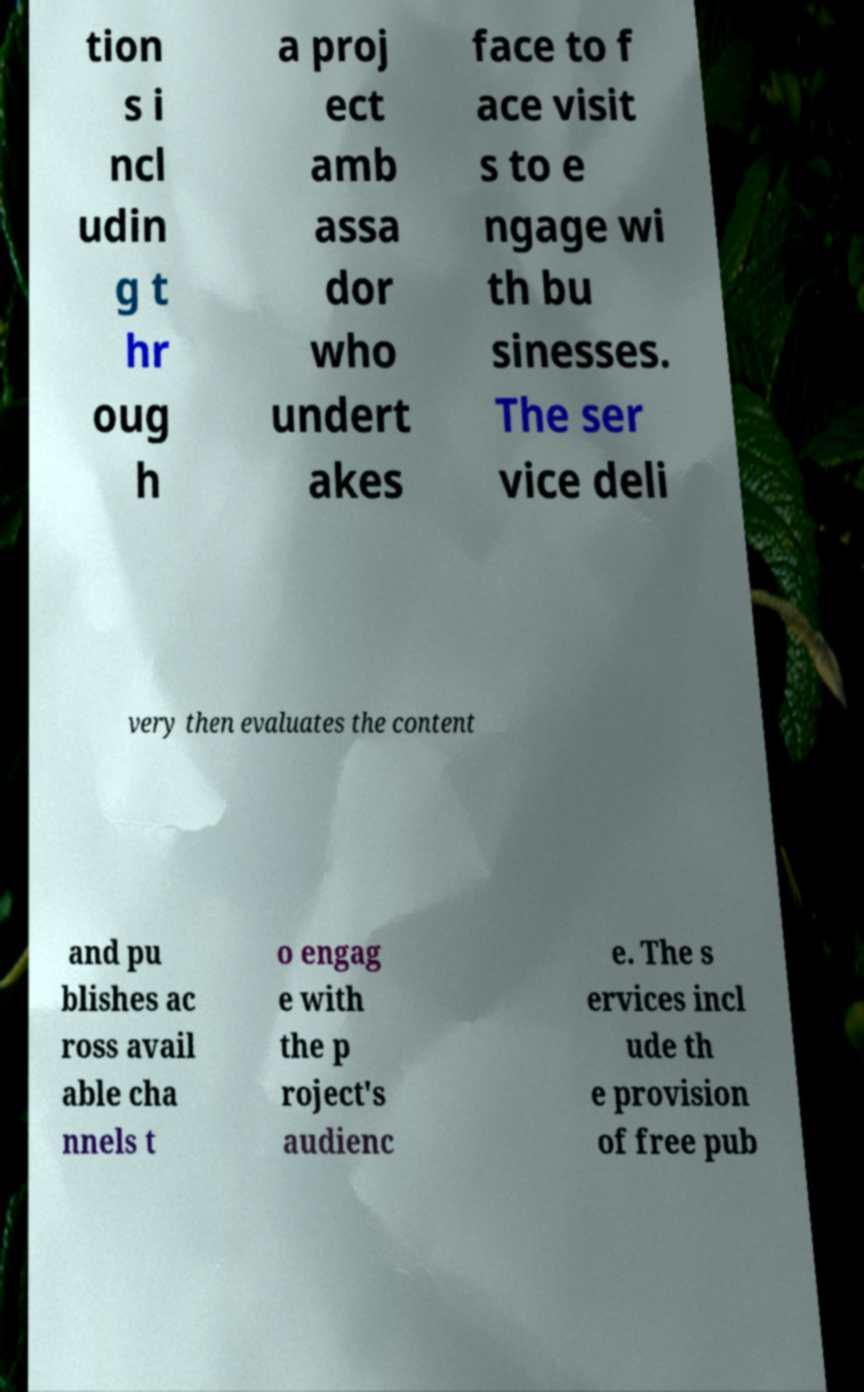I need the written content from this picture converted into text. Can you do that? tion s i ncl udin g t hr oug h a proj ect amb assa dor who undert akes face to f ace visit s to e ngage wi th bu sinesses. The ser vice deli very then evaluates the content and pu blishes ac ross avail able cha nnels t o engag e with the p roject's audienc e. The s ervices incl ude th e provision of free pub 